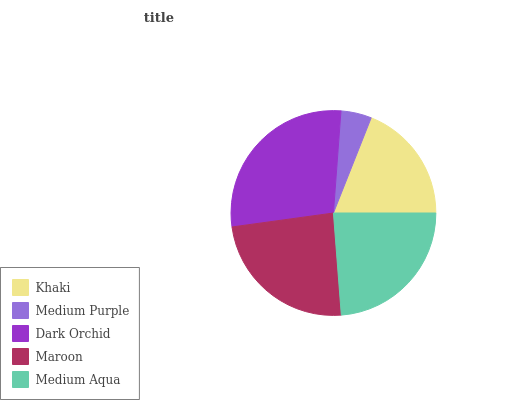Is Medium Purple the minimum?
Answer yes or no. Yes. Is Dark Orchid the maximum?
Answer yes or no. Yes. Is Dark Orchid the minimum?
Answer yes or no. No. Is Medium Purple the maximum?
Answer yes or no. No. Is Dark Orchid greater than Medium Purple?
Answer yes or no. Yes. Is Medium Purple less than Dark Orchid?
Answer yes or no. Yes. Is Medium Purple greater than Dark Orchid?
Answer yes or no. No. Is Dark Orchid less than Medium Purple?
Answer yes or no. No. Is Medium Aqua the high median?
Answer yes or no. Yes. Is Medium Aqua the low median?
Answer yes or no. Yes. Is Khaki the high median?
Answer yes or no. No. Is Maroon the low median?
Answer yes or no. No. 